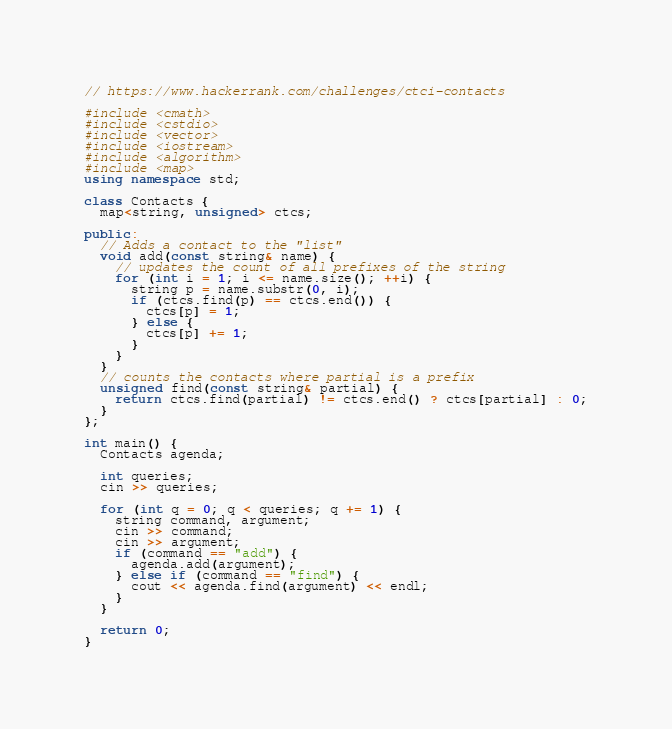Convert code to text. <code><loc_0><loc_0><loc_500><loc_500><_C++_>// https://www.hackerrank.com/challenges/ctci-contacts

#include <cmath>
#include <cstdio>
#include <vector>
#include <iostream>
#include <algorithm>
#include <map>
using namespace std;

class Contacts {
  map<string, unsigned> ctcs;
  
public:
  // Adds a contact to the "list"
  void add(const string& name) {
    // updates the count of all prefixes of the string
    for (int i = 1; i <= name.size(); ++i) {
      string p = name.substr(0, i);
      if (ctcs.find(p) == ctcs.end()) {
        ctcs[p] = 1;   
      } else {
        ctcs[p] += 1;
      }
    }
  }
  // counts the contacts where partial is a prefix
  unsigned find(const string& partial) {
    return ctcs.find(partial) != ctcs.end() ? ctcs[partial] : 0;
  }
};

int main() {
  Contacts agenda;
    
  int queries;
  cin >> queries;
    
  for (int q = 0; q < queries; q += 1) {
    string command, argument;
    cin >> command;
    cin >> argument;
    if (command == "add") {
      agenda.add(argument);
    } else if (command == "find") {
      cout << agenda.find(argument) << endl;
    }
  }
    
  return 0;
}
</code> 